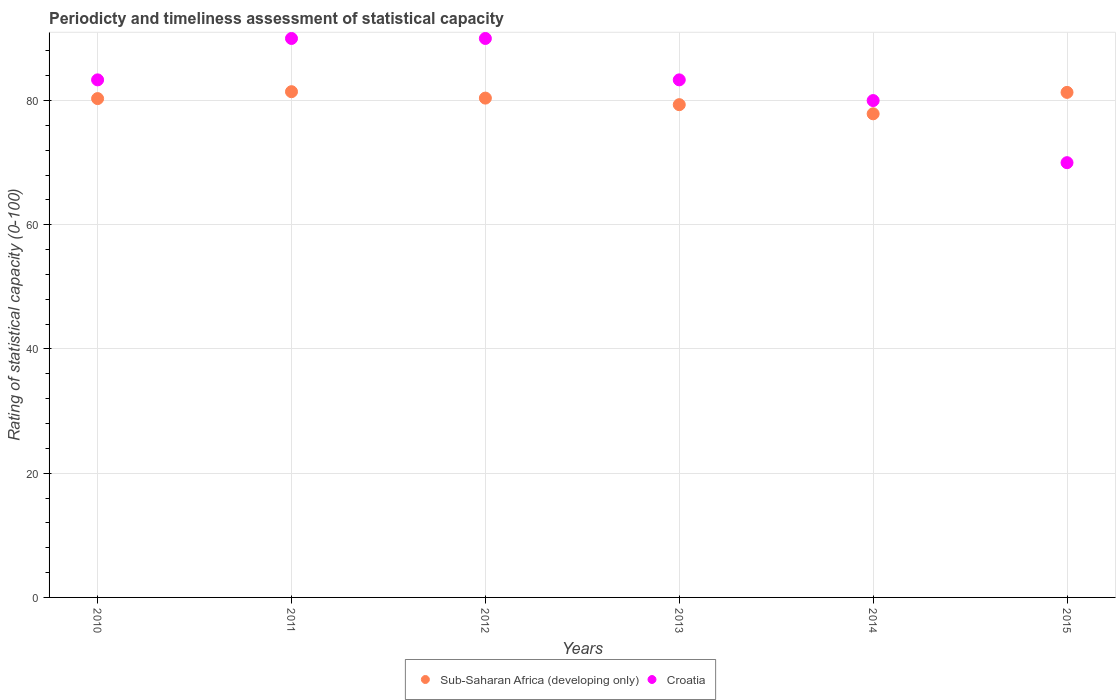How many different coloured dotlines are there?
Provide a succinct answer. 2. Is the number of dotlines equal to the number of legend labels?
Your answer should be very brief. Yes. What is the rating of statistical capacity in Croatia in 2012?
Your response must be concise. 90. Across all years, what is the maximum rating of statistical capacity in Sub-Saharan Africa (developing only)?
Provide a succinct answer. 81.43. Across all years, what is the minimum rating of statistical capacity in Sub-Saharan Africa (developing only)?
Provide a short and direct response. 77.87. In which year was the rating of statistical capacity in Sub-Saharan Africa (developing only) maximum?
Provide a short and direct response. 2011. In which year was the rating of statistical capacity in Croatia minimum?
Your answer should be very brief. 2015. What is the total rating of statistical capacity in Croatia in the graph?
Make the answer very short. 496.67. What is the difference between the rating of statistical capacity in Croatia in 2015 and the rating of statistical capacity in Sub-Saharan Africa (developing only) in 2014?
Your response must be concise. -7.87. What is the average rating of statistical capacity in Sub-Saharan Africa (developing only) per year?
Provide a short and direct response. 80.11. In the year 2015, what is the difference between the rating of statistical capacity in Sub-Saharan Africa (developing only) and rating of statistical capacity in Croatia?
Provide a short and direct response. 11.32. In how many years, is the rating of statistical capacity in Croatia greater than 56?
Your answer should be very brief. 6. What is the ratio of the rating of statistical capacity in Croatia in 2014 to that in 2015?
Your response must be concise. 1.14. Is the rating of statistical capacity in Sub-Saharan Africa (developing only) in 2011 less than that in 2013?
Keep it short and to the point. No. What is the difference between the highest and the second highest rating of statistical capacity in Croatia?
Offer a terse response. 0. What is the difference between the highest and the lowest rating of statistical capacity in Croatia?
Your answer should be compact. 20. In how many years, is the rating of statistical capacity in Croatia greater than the average rating of statistical capacity in Croatia taken over all years?
Offer a very short reply. 4. Is the sum of the rating of statistical capacity in Sub-Saharan Africa (developing only) in 2010 and 2015 greater than the maximum rating of statistical capacity in Croatia across all years?
Keep it short and to the point. Yes. Does the rating of statistical capacity in Croatia monotonically increase over the years?
Provide a succinct answer. No. How many dotlines are there?
Ensure brevity in your answer.  2. How many years are there in the graph?
Provide a succinct answer. 6. What is the difference between two consecutive major ticks on the Y-axis?
Your response must be concise. 20. Are the values on the major ticks of Y-axis written in scientific E-notation?
Ensure brevity in your answer.  No. Does the graph contain any zero values?
Keep it short and to the point. No. Does the graph contain grids?
Keep it short and to the point. Yes. How many legend labels are there?
Give a very brief answer. 2. What is the title of the graph?
Your response must be concise. Periodicty and timeliness assessment of statistical capacity. What is the label or title of the Y-axis?
Give a very brief answer. Rating of statistical capacity (0-100). What is the Rating of statistical capacity (0-100) in Sub-Saharan Africa (developing only) in 2010?
Make the answer very short. 80.32. What is the Rating of statistical capacity (0-100) in Croatia in 2010?
Provide a succinct answer. 83.33. What is the Rating of statistical capacity (0-100) of Sub-Saharan Africa (developing only) in 2011?
Your response must be concise. 81.43. What is the Rating of statistical capacity (0-100) of Croatia in 2011?
Your answer should be compact. 90. What is the Rating of statistical capacity (0-100) in Sub-Saharan Africa (developing only) in 2012?
Give a very brief answer. 80.4. What is the Rating of statistical capacity (0-100) in Croatia in 2012?
Provide a succinct answer. 90. What is the Rating of statistical capacity (0-100) of Sub-Saharan Africa (developing only) in 2013?
Your answer should be compact. 79.34. What is the Rating of statistical capacity (0-100) in Croatia in 2013?
Provide a succinct answer. 83.33. What is the Rating of statistical capacity (0-100) in Sub-Saharan Africa (developing only) in 2014?
Ensure brevity in your answer.  77.87. What is the Rating of statistical capacity (0-100) in Sub-Saharan Africa (developing only) in 2015?
Keep it short and to the point. 81.32. What is the Rating of statistical capacity (0-100) of Croatia in 2015?
Provide a short and direct response. 70. Across all years, what is the maximum Rating of statistical capacity (0-100) of Sub-Saharan Africa (developing only)?
Make the answer very short. 81.43. Across all years, what is the minimum Rating of statistical capacity (0-100) of Sub-Saharan Africa (developing only)?
Provide a short and direct response. 77.87. Across all years, what is the minimum Rating of statistical capacity (0-100) in Croatia?
Offer a very short reply. 70. What is the total Rating of statistical capacity (0-100) of Sub-Saharan Africa (developing only) in the graph?
Keep it short and to the point. 480.67. What is the total Rating of statistical capacity (0-100) of Croatia in the graph?
Your answer should be very brief. 496.67. What is the difference between the Rating of statistical capacity (0-100) of Sub-Saharan Africa (developing only) in 2010 and that in 2011?
Give a very brief answer. -1.11. What is the difference between the Rating of statistical capacity (0-100) in Croatia in 2010 and that in 2011?
Give a very brief answer. -6.67. What is the difference between the Rating of statistical capacity (0-100) of Sub-Saharan Africa (developing only) in 2010 and that in 2012?
Offer a terse response. -0.08. What is the difference between the Rating of statistical capacity (0-100) in Croatia in 2010 and that in 2012?
Your answer should be compact. -6.67. What is the difference between the Rating of statistical capacity (0-100) of Sub-Saharan Africa (developing only) in 2010 and that in 2013?
Your answer should be compact. 0.98. What is the difference between the Rating of statistical capacity (0-100) of Croatia in 2010 and that in 2013?
Your response must be concise. -0. What is the difference between the Rating of statistical capacity (0-100) of Sub-Saharan Africa (developing only) in 2010 and that in 2014?
Ensure brevity in your answer.  2.45. What is the difference between the Rating of statistical capacity (0-100) of Sub-Saharan Africa (developing only) in 2010 and that in 2015?
Make the answer very short. -1. What is the difference between the Rating of statistical capacity (0-100) in Croatia in 2010 and that in 2015?
Your answer should be compact. 13.33. What is the difference between the Rating of statistical capacity (0-100) of Sub-Saharan Africa (developing only) in 2011 and that in 2012?
Offer a terse response. 1.03. What is the difference between the Rating of statistical capacity (0-100) in Sub-Saharan Africa (developing only) in 2011 and that in 2013?
Your answer should be very brief. 2.09. What is the difference between the Rating of statistical capacity (0-100) of Sub-Saharan Africa (developing only) in 2011 and that in 2014?
Provide a short and direct response. 3.56. What is the difference between the Rating of statistical capacity (0-100) in Sub-Saharan Africa (developing only) in 2011 and that in 2015?
Ensure brevity in your answer.  0.11. What is the difference between the Rating of statistical capacity (0-100) of Croatia in 2011 and that in 2015?
Your answer should be compact. 20. What is the difference between the Rating of statistical capacity (0-100) in Sub-Saharan Africa (developing only) in 2012 and that in 2013?
Your answer should be very brief. 1.06. What is the difference between the Rating of statistical capacity (0-100) of Croatia in 2012 and that in 2013?
Your answer should be very brief. 6.67. What is the difference between the Rating of statistical capacity (0-100) in Sub-Saharan Africa (developing only) in 2012 and that in 2014?
Provide a short and direct response. 2.53. What is the difference between the Rating of statistical capacity (0-100) of Croatia in 2012 and that in 2014?
Your answer should be compact. 10. What is the difference between the Rating of statistical capacity (0-100) in Sub-Saharan Africa (developing only) in 2012 and that in 2015?
Offer a very short reply. -0.92. What is the difference between the Rating of statistical capacity (0-100) in Croatia in 2012 and that in 2015?
Your answer should be very brief. 20. What is the difference between the Rating of statistical capacity (0-100) of Sub-Saharan Africa (developing only) in 2013 and that in 2014?
Offer a terse response. 1.47. What is the difference between the Rating of statistical capacity (0-100) of Croatia in 2013 and that in 2014?
Provide a short and direct response. 3.33. What is the difference between the Rating of statistical capacity (0-100) in Sub-Saharan Africa (developing only) in 2013 and that in 2015?
Your answer should be very brief. -1.98. What is the difference between the Rating of statistical capacity (0-100) of Croatia in 2013 and that in 2015?
Give a very brief answer. 13.33. What is the difference between the Rating of statistical capacity (0-100) in Sub-Saharan Africa (developing only) in 2014 and that in 2015?
Provide a short and direct response. -3.45. What is the difference between the Rating of statistical capacity (0-100) in Croatia in 2014 and that in 2015?
Give a very brief answer. 10. What is the difference between the Rating of statistical capacity (0-100) in Sub-Saharan Africa (developing only) in 2010 and the Rating of statistical capacity (0-100) in Croatia in 2011?
Make the answer very short. -9.68. What is the difference between the Rating of statistical capacity (0-100) in Sub-Saharan Africa (developing only) in 2010 and the Rating of statistical capacity (0-100) in Croatia in 2012?
Give a very brief answer. -9.68. What is the difference between the Rating of statistical capacity (0-100) of Sub-Saharan Africa (developing only) in 2010 and the Rating of statistical capacity (0-100) of Croatia in 2013?
Provide a short and direct response. -3.02. What is the difference between the Rating of statistical capacity (0-100) of Sub-Saharan Africa (developing only) in 2010 and the Rating of statistical capacity (0-100) of Croatia in 2014?
Provide a succinct answer. 0.32. What is the difference between the Rating of statistical capacity (0-100) of Sub-Saharan Africa (developing only) in 2010 and the Rating of statistical capacity (0-100) of Croatia in 2015?
Ensure brevity in your answer.  10.32. What is the difference between the Rating of statistical capacity (0-100) of Sub-Saharan Africa (developing only) in 2011 and the Rating of statistical capacity (0-100) of Croatia in 2012?
Your answer should be compact. -8.57. What is the difference between the Rating of statistical capacity (0-100) of Sub-Saharan Africa (developing only) in 2011 and the Rating of statistical capacity (0-100) of Croatia in 2013?
Your answer should be very brief. -1.9. What is the difference between the Rating of statistical capacity (0-100) of Sub-Saharan Africa (developing only) in 2011 and the Rating of statistical capacity (0-100) of Croatia in 2014?
Your response must be concise. 1.43. What is the difference between the Rating of statistical capacity (0-100) in Sub-Saharan Africa (developing only) in 2011 and the Rating of statistical capacity (0-100) in Croatia in 2015?
Ensure brevity in your answer.  11.43. What is the difference between the Rating of statistical capacity (0-100) in Sub-Saharan Africa (developing only) in 2012 and the Rating of statistical capacity (0-100) in Croatia in 2013?
Make the answer very short. -2.94. What is the difference between the Rating of statistical capacity (0-100) of Sub-Saharan Africa (developing only) in 2012 and the Rating of statistical capacity (0-100) of Croatia in 2014?
Provide a succinct answer. 0.4. What is the difference between the Rating of statistical capacity (0-100) in Sub-Saharan Africa (developing only) in 2012 and the Rating of statistical capacity (0-100) in Croatia in 2015?
Ensure brevity in your answer.  10.4. What is the difference between the Rating of statistical capacity (0-100) in Sub-Saharan Africa (developing only) in 2013 and the Rating of statistical capacity (0-100) in Croatia in 2014?
Your response must be concise. -0.66. What is the difference between the Rating of statistical capacity (0-100) of Sub-Saharan Africa (developing only) in 2013 and the Rating of statistical capacity (0-100) of Croatia in 2015?
Keep it short and to the point. 9.34. What is the difference between the Rating of statistical capacity (0-100) of Sub-Saharan Africa (developing only) in 2014 and the Rating of statistical capacity (0-100) of Croatia in 2015?
Ensure brevity in your answer.  7.87. What is the average Rating of statistical capacity (0-100) of Sub-Saharan Africa (developing only) per year?
Offer a terse response. 80.11. What is the average Rating of statistical capacity (0-100) of Croatia per year?
Give a very brief answer. 82.78. In the year 2010, what is the difference between the Rating of statistical capacity (0-100) in Sub-Saharan Africa (developing only) and Rating of statistical capacity (0-100) in Croatia?
Offer a very short reply. -3.02. In the year 2011, what is the difference between the Rating of statistical capacity (0-100) of Sub-Saharan Africa (developing only) and Rating of statistical capacity (0-100) of Croatia?
Your answer should be compact. -8.57. In the year 2012, what is the difference between the Rating of statistical capacity (0-100) in Sub-Saharan Africa (developing only) and Rating of statistical capacity (0-100) in Croatia?
Your response must be concise. -9.6. In the year 2013, what is the difference between the Rating of statistical capacity (0-100) of Sub-Saharan Africa (developing only) and Rating of statistical capacity (0-100) of Croatia?
Give a very brief answer. -3.99. In the year 2014, what is the difference between the Rating of statistical capacity (0-100) of Sub-Saharan Africa (developing only) and Rating of statistical capacity (0-100) of Croatia?
Provide a short and direct response. -2.13. In the year 2015, what is the difference between the Rating of statistical capacity (0-100) of Sub-Saharan Africa (developing only) and Rating of statistical capacity (0-100) of Croatia?
Your answer should be very brief. 11.32. What is the ratio of the Rating of statistical capacity (0-100) in Sub-Saharan Africa (developing only) in 2010 to that in 2011?
Your response must be concise. 0.99. What is the ratio of the Rating of statistical capacity (0-100) of Croatia in 2010 to that in 2011?
Offer a terse response. 0.93. What is the ratio of the Rating of statistical capacity (0-100) of Croatia in 2010 to that in 2012?
Offer a very short reply. 0.93. What is the ratio of the Rating of statistical capacity (0-100) in Sub-Saharan Africa (developing only) in 2010 to that in 2013?
Offer a very short reply. 1.01. What is the ratio of the Rating of statistical capacity (0-100) in Croatia in 2010 to that in 2013?
Offer a very short reply. 1. What is the ratio of the Rating of statistical capacity (0-100) in Sub-Saharan Africa (developing only) in 2010 to that in 2014?
Give a very brief answer. 1.03. What is the ratio of the Rating of statistical capacity (0-100) in Croatia in 2010 to that in 2014?
Offer a very short reply. 1.04. What is the ratio of the Rating of statistical capacity (0-100) of Sub-Saharan Africa (developing only) in 2010 to that in 2015?
Provide a succinct answer. 0.99. What is the ratio of the Rating of statistical capacity (0-100) in Croatia in 2010 to that in 2015?
Your response must be concise. 1.19. What is the ratio of the Rating of statistical capacity (0-100) in Sub-Saharan Africa (developing only) in 2011 to that in 2012?
Provide a short and direct response. 1.01. What is the ratio of the Rating of statistical capacity (0-100) of Croatia in 2011 to that in 2012?
Keep it short and to the point. 1. What is the ratio of the Rating of statistical capacity (0-100) in Sub-Saharan Africa (developing only) in 2011 to that in 2013?
Make the answer very short. 1.03. What is the ratio of the Rating of statistical capacity (0-100) in Croatia in 2011 to that in 2013?
Offer a terse response. 1.08. What is the ratio of the Rating of statistical capacity (0-100) of Sub-Saharan Africa (developing only) in 2011 to that in 2014?
Your response must be concise. 1.05. What is the ratio of the Rating of statistical capacity (0-100) in Croatia in 2011 to that in 2014?
Ensure brevity in your answer.  1.12. What is the ratio of the Rating of statistical capacity (0-100) in Sub-Saharan Africa (developing only) in 2011 to that in 2015?
Your response must be concise. 1. What is the ratio of the Rating of statistical capacity (0-100) in Croatia in 2011 to that in 2015?
Ensure brevity in your answer.  1.29. What is the ratio of the Rating of statistical capacity (0-100) in Sub-Saharan Africa (developing only) in 2012 to that in 2013?
Your response must be concise. 1.01. What is the ratio of the Rating of statistical capacity (0-100) of Croatia in 2012 to that in 2013?
Your answer should be very brief. 1.08. What is the ratio of the Rating of statistical capacity (0-100) of Sub-Saharan Africa (developing only) in 2012 to that in 2014?
Your answer should be very brief. 1.03. What is the ratio of the Rating of statistical capacity (0-100) of Sub-Saharan Africa (developing only) in 2012 to that in 2015?
Ensure brevity in your answer.  0.99. What is the ratio of the Rating of statistical capacity (0-100) of Sub-Saharan Africa (developing only) in 2013 to that in 2014?
Your answer should be very brief. 1.02. What is the ratio of the Rating of statistical capacity (0-100) in Croatia in 2013 to that in 2014?
Provide a short and direct response. 1.04. What is the ratio of the Rating of statistical capacity (0-100) of Sub-Saharan Africa (developing only) in 2013 to that in 2015?
Give a very brief answer. 0.98. What is the ratio of the Rating of statistical capacity (0-100) of Croatia in 2013 to that in 2015?
Make the answer very short. 1.19. What is the ratio of the Rating of statistical capacity (0-100) in Sub-Saharan Africa (developing only) in 2014 to that in 2015?
Provide a succinct answer. 0.96. What is the difference between the highest and the second highest Rating of statistical capacity (0-100) of Sub-Saharan Africa (developing only)?
Provide a succinct answer. 0.11. What is the difference between the highest and the lowest Rating of statistical capacity (0-100) of Sub-Saharan Africa (developing only)?
Make the answer very short. 3.56. What is the difference between the highest and the lowest Rating of statistical capacity (0-100) of Croatia?
Make the answer very short. 20. 